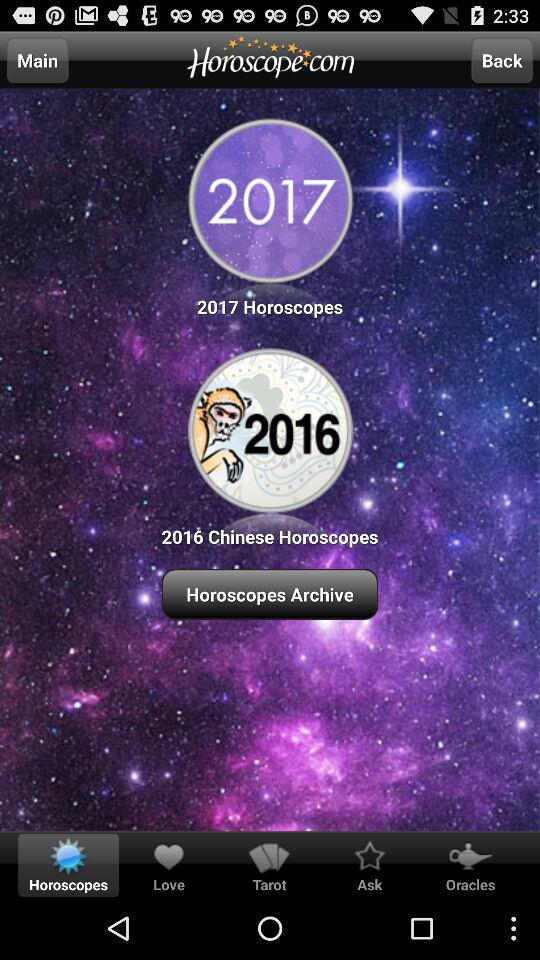Which tab am I using? You are using "Horoscopes" tab. 